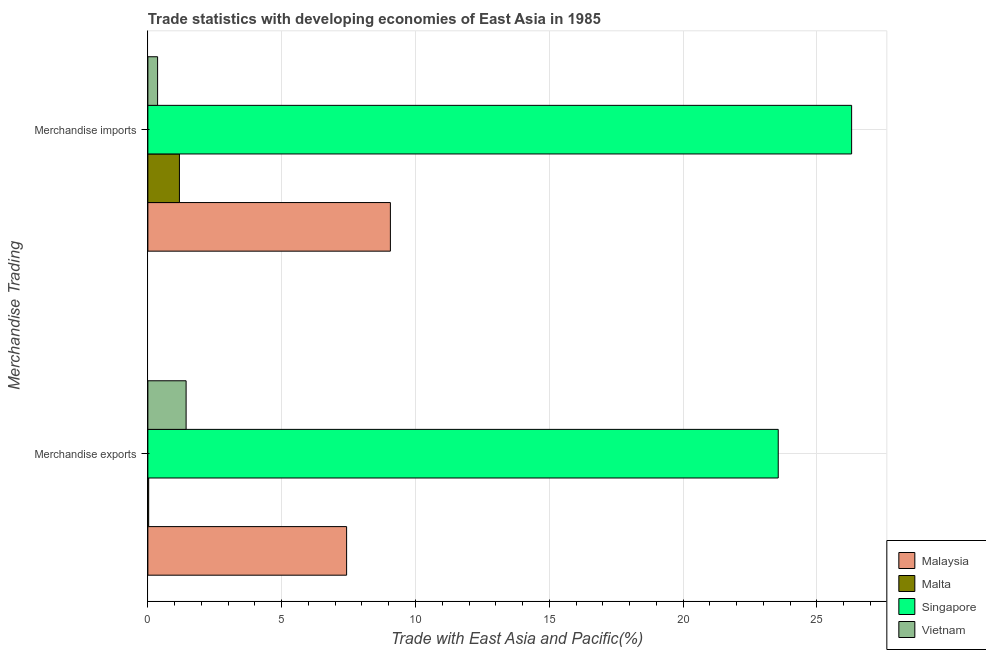How many groups of bars are there?
Your answer should be compact. 2. Are the number of bars on each tick of the Y-axis equal?
Offer a terse response. Yes. How many bars are there on the 2nd tick from the top?
Offer a terse response. 4. What is the label of the 2nd group of bars from the top?
Your answer should be compact. Merchandise exports. What is the merchandise imports in Singapore?
Ensure brevity in your answer.  26.3. Across all countries, what is the maximum merchandise imports?
Your answer should be compact. 26.3. Across all countries, what is the minimum merchandise imports?
Offer a very short reply. 0.36. In which country was the merchandise exports maximum?
Offer a very short reply. Singapore. In which country was the merchandise exports minimum?
Keep it short and to the point. Malta. What is the total merchandise exports in the graph?
Make the answer very short. 32.44. What is the difference between the merchandise exports in Vietnam and that in Malaysia?
Your response must be concise. -6. What is the difference between the merchandise imports in Malaysia and the merchandise exports in Singapore?
Make the answer very short. -14.49. What is the average merchandise exports per country?
Give a very brief answer. 8.11. What is the difference between the merchandise imports and merchandise exports in Malaysia?
Provide a succinct answer. 1.64. In how many countries, is the merchandise imports greater than 15 %?
Ensure brevity in your answer.  1. What is the ratio of the merchandise exports in Vietnam to that in Singapore?
Your answer should be very brief. 0.06. Is the merchandise exports in Vietnam less than that in Malaysia?
Ensure brevity in your answer.  Yes. In how many countries, is the merchandise imports greater than the average merchandise imports taken over all countries?
Provide a short and direct response. 1. What does the 1st bar from the top in Merchandise imports represents?
Give a very brief answer. Vietnam. What does the 3rd bar from the bottom in Merchandise imports represents?
Offer a terse response. Singapore. How many bars are there?
Provide a succinct answer. 8. Are all the bars in the graph horizontal?
Give a very brief answer. Yes. How many countries are there in the graph?
Offer a very short reply. 4. How are the legend labels stacked?
Offer a very short reply. Vertical. What is the title of the graph?
Offer a very short reply. Trade statistics with developing economies of East Asia in 1985. Does "Cayman Islands" appear as one of the legend labels in the graph?
Ensure brevity in your answer.  No. What is the label or title of the X-axis?
Your answer should be very brief. Trade with East Asia and Pacific(%). What is the label or title of the Y-axis?
Offer a terse response. Merchandise Trading. What is the Trade with East Asia and Pacific(%) in Malaysia in Merchandise exports?
Your answer should be very brief. 7.43. What is the Trade with East Asia and Pacific(%) in Malta in Merchandise exports?
Your answer should be very brief. 0.03. What is the Trade with East Asia and Pacific(%) in Singapore in Merchandise exports?
Provide a succinct answer. 23.55. What is the Trade with East Asia and Pacific(%) in Vietnam in Merchandise exports?
Keep it short and to the point. 1.43. What is the Trade with East Asia and Pacific(%) in Malaysia in Merchandise imports?
Your answer should be very brief. 9.06. What is the Trade with East Asia and Pacific(%) of Malta in Merchandise imports?
Offer a very short reply. 1.18. What is the Trade with East Asia and Pacific(%) of Singapore in Merchandise imports?
Offer a very short reply. 26.3. What is the Trade with East Asia and Pacific(%) in Vietnam in Merchandise imports?
Make the answer very short. 0.36. Across all Merchandise Trading, what is the maximum Trade with East Asia and Pacific(%) of Malaysia?
Offer a very short reply. 9.06. Across all Merchandise Trading, what is the maximum Trade with East Asia and Pacific(%) of Malta?
Your response must be concise. 1.18. Across all Merchandise Trading, what is the maximum Trade with East Asia and Pacific(%) of Singapore?
Offer a very short reply. 26.3. Across all Merchandise Trading, what is the maximum Trade with East Asia and Pacific(%) of Vietnam?
Ensure brevity in your answer.  1.43. Across all Merchandise Trading, what is the minimum Trade with East Asia and Pacific(%) of Malaysia?
Your answer should be very brief. 7.43. Across all Merchandise Trading, what is the minimum Trade with East Asia and Pacific(%) in Malta?
Make the answer very short. 0.03. Across all Merchandise Trading, what is the minimum Trade with East Asia and Pacific(%) in Singapore?
Your response must be concise. 23.55. Across all Merchandise Trading, what is the minimum Trade with East Asia and Pacific(%) in Vietnam?
Offer a terse response. 0.36. What is the total Trade with East Asia and Pacific(%) in Malaysia in the graph?
Keep it short and to the point. 16.49. What is the total Trade with East Asia and Pacific(%) of Malta in the graph?
Make the answer very short. 1.21. What is the total Trade with East Asia and Pacific(%) of Singapore in the graph?
Make the answer very short. 49.85. What is the total Trade with East Asia and Pacific(%) in Vietnam in the graph?
Make the answer very short. 1.79. What is the difference between the Trade with East Asia and Pacific(%) in Malaysia in Merchandise exports and that in Merchandise imports?
Your response must be concise. -1.64. What is the difference between the Trade with East Asia and Pacific(%) in Malta in Merchandise exports and that in Merchandise imports?
Provide a succinct answer. -1.15. What is the difference between the Trade with East Asia and Pacific(%) in Singapore in Merchandise exports and that in Merchandise imports?
Provide a short and direct response. -2.74. What is the difference between the Trade with East Asia and Pacific(%) of Vietnam in Merchandise exports and that in Merchandise imports?
Offer a very short reply. 1.07. What is the difference between the Trade with East Asia and Pacific(%) of Malaysia in Merchandise exports and the Trade with East Asia and Pacific(%) of Malta in Merchandise imports?
Provide a succinct answer. 6.25. What is the difference between the Trade with East Asia and Pacific(%) in Malaysia in Merchandise exports and the Trade with East Asia and Pacific(%) in Singapore in Merchandise imports?
Your answer should be very brief. -18.87. What is the difference between the Trade with East Asia and Pacific(%) in Malaysia in Merchandise exports and the Trade with East Asia and Pacific(%) in Vietnam in Merchandise imports?
Offer a terse response. 7.06. What is the difference between the Trade with East Asia and Pacific(%) of Malta in Merchandise exports and the Trade with East Asia and Pacific(%) of Singapore in Merchandise imports?
Offer a very short reply. -26.27. What is the difference between the Trade with East Asia and Pacific(%) in Malta in Merchandise exports and the Trade with East Asia and Pacific(%) in Vietnam in Merchandise imports?
Offer a very short reply. -0.33. What is the difference between the Trade with East Asia and Pacific(%) of Singapore in Merchandise exports and the Trade with East Asia and Pacific(%) of Vietnam in Merchandise imports?
Your answer should be compact. 23.19. What is the average Trade with East Asia and Pacific(%) in Malaysia per Merchandise Trading?
Offer a very short reply. 8.24. What is the average Trade with East Asia and Pacific(%) of Malta per Merchandise Trading?
Your response must be concise. 0.6. What is the average Trade with East Asia and Pacific(%) in Singapore per Merchandise Trading?
Offer a terse response. 24.93. What is the average Trade with East Asia and Pacific(%) in Vietnam per Merchandise Trading?
Your response must be concise. 0.9. What is the difference between the Trade with East Asia and Pacific(%) in Malaysia and Trade with East Asia and Pacific(%) in Malta in Merchandise exports?
Provide a succinct answer. 7.4. What is the difference between the Trade with East Asia and Pacific(%) of Malaysia and Trade with East Asia and Pacific(%) of Singapore in Merchandise exports?
Ensure brevity in your answer.  -16.13. What is the difference between the Trade with East Asia and Pacific(%) in Malaysia and Trade with East Asia and Pacific(%) in Vietnam in Merchandise exports?
Your response must be concise. 6. What is the difference between the Trade with East Asia and Pacific(%) of Malta and Trade with East Asia and Pacific(%) of Singapore in Merchandise exports?
Your response must be concise. -23.52. What is the difference between the Trade with East Asia and Pacific(%) in Malta and Trade with East Asia and Pacific(%) in Vietnam in Merchandise exports?
Provide a short and direct response. -1.4. What is the difference between the Trade with East Asia and Pacific(%) of Singapore and Trade with East Asia and Pacific(%) of Vietnam in Merchandise exports?
Provide a succinct answer. 22.12. What is the difference between the Trade with East Asia and Pacific(%) in Malaysia and Trade with East Asia and Pacific(%) in Malta in Merchandise imports?
Provide a succinct answer. 7.88. What is the difference between the Trade with East Asia and Pacific(%) in Malaysia and Trade with East Asia and Pacific(%) in Singapore in Merchandise imports?
Your answer should be compact. -17.23. What is the difference between the Trade with East Asia and Pacific(%) of Malaysia and Trade with East Asia and Pacific(%) of Vietnam in Merchandise imports?
Provide a short and direct response. 8.7. What is the difference between the Trade with East Asia and Pacific(%) in Malta and Trade with East Asia and Pacific(%) in Singapore in Merchandise imports?
Your answer should be very brief. -25.12. What is the difference between the Trade with East Asia and Pacific(%) of Malta and Trade with East Asia and Pacific(%) of Vietnam in Merchandise imports?
Keep it short and to the point. 0.82. What is the difference between the Trade with East Asia and Pacific(%) in Singapore and Trade with East Asia and Pacific(%) in Vietnam in Merchandise imports?
Give a very brief answer. 25.93. What is the ratio of the Trade with East Asia and Pacific(%) of Malaysia in Merchandise exports to that in Merchandise imports?
Provide a short and direct response. 0.82. What is the ratio of the Trade with East Asia and Pacific(%) in Malta in Merchandise exports to that in Merchandise imports?
Offer a terse response. 0.03. What is the ratio of the Trade with East Asia and Pacific(%) of Singapore in Merchandise exports to that in Merchandise imports?
Your answer should be very brief. 0.9. What is the ratio of the Trade with East Asia and Pacific(%) of Vietnam in Merchandise exports to that in Merchandise imports?
Your response must be concise. 3.93. What is the difference between the highest and the second highest Trade with East Asia and Pacific(%) of Malaysia?
Keep it short and to the point. 1.64. What is the difference between the highest and the second highest Trade with East Asia and Pacific(%) of Malta?
Ensure brevity in your answer.  1.15. What is the difference between the highest and the second highest Trade with East Asia and Pacific(%) of Singapore?
Give a very brief answer. 2.74. What is the difference between the highest and the second highest Trade with East Asia and Pacific(%) in Vietnam?
Your answer should be compact. 1.07. What is the difference between the highest and the lowest Trade with East Asia and Pacific(%) of Malaysia?
Offer a terse response. 1.64. What is the difference between the highest and the lowest Trade with East Asia and Pacific(%) of Malta?
Keep it short and to the point. 1.15. What is the difference between the highest and the lowest Trade with East Asia and Pacific(%) in Singapore?
Your answer should be very brief. 2.74. What is the difference between the highest and the lowest Trade with East Asia and Pacific(%) in Vietnam?
Keep it short and to the point. 1.07. 